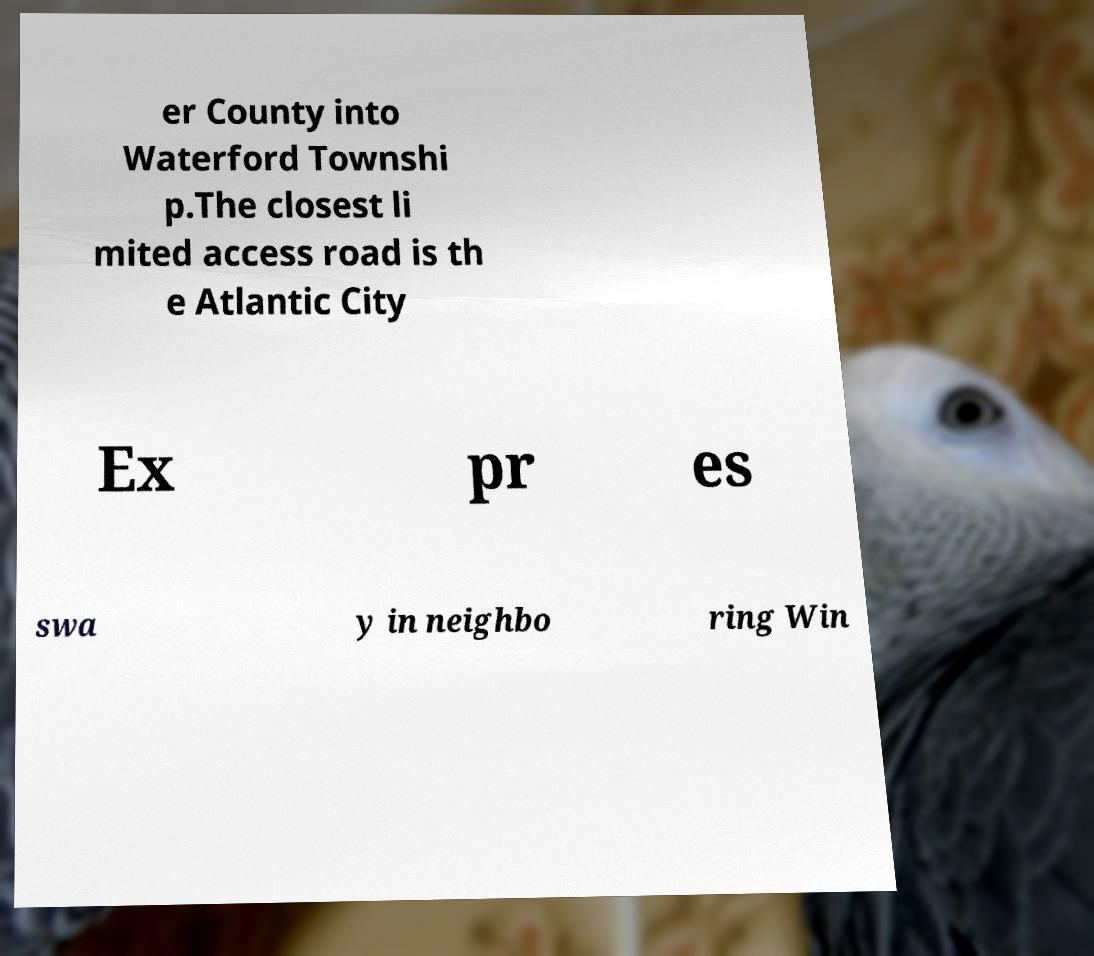Could you assist in decoding the text presented in this image and type it out clearly? er County into Waterford Townshi p.The closest li mited access road is th e Atlantic City Ex pr es swa y in neighbo ring Win 